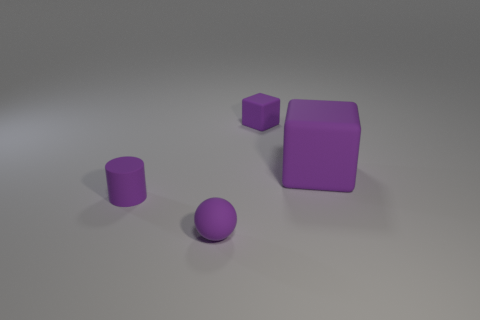There is a tiny rubber sphere; are there any large purple objects in front of it?
Your answer should be very brief. No. Are there the same number of tiny rubber things behind the big thing and tiny matte blocks?
Offer a terse response. Yes. Are there any small matte balls in front of the purple matte thing to the right of the purple matte cube behind the big purple block?
Provide a succinct answer. Yes. What material is the large cube?
Provide a succinct answer. Rubber. What number of other objects are the same shape as the big thing?
Keep it short and to the point. 1. What number of objects are either small purple rubber objects that are right of the tiny ball or matte objects that are on the left side of the purple sphere?
Keep it short and to the point. 2. What number of objects are either small red cylinders or purple cubes?
Your response must be concise. 2. What number of tiny objects are on the left side of the tiny object that is behind the tiny rubber cylinder?
Offer a terse response. 2. How many other things are there of the same size as the rubber ball?
Provide a short and direct response. 2. The other matte block that is the same color as the large matte cube is what size?
Ensure brevity in your answer.  Small. 